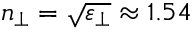<formula> <loc_0><loc_0><loc_500><loc_500>n _ { \perp } = \sqrt { \varepsilon _ { \perp } } \approx 1 . 5 4</formula> 